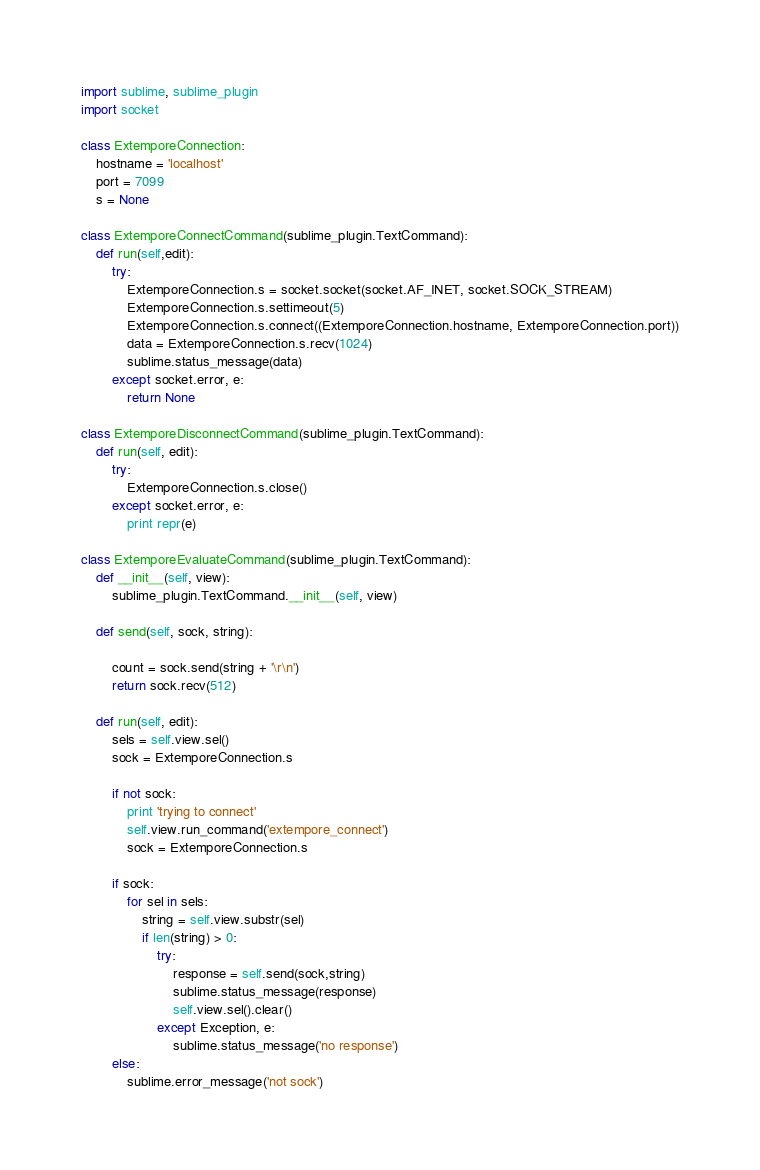<code> <loc_0><loc_0><loc_500><loc_500><_Python_>import sublime, sublime_plugin
import socket

class ExtemporeConnection:
	hostname = 'localhost'
	port = 7099
	s = None

class ExtemporeConnectCommand(sublime_plugin.TextCommand):
	def run(self,edit):
		try:
			ExtemporeConnection.s = socket.socket(socket.AF_INET, socket.SOCK_STREAM)
			ExtemporeConnection.s.settimeout(5)
			ExtemporeConnection.s.connect((ExtemporeConnection.hostname, ExtemporeConnection.port))
			data = ExtemporeConnection.s.recv(1024)
			sublime.status_message(data)
		except socket.error, e:
			return None

class ExtemporeDisconnectCommand(sublime_plugin.TextCommand):
	def run(self, edit):
		try:
			ExtemporeConnection.s.close()
		except socket.error, e:
			print repr(e)

class ExtemporeEvaluateCommand(sublime_plugin.TextCommand):
	def __init__(self, view):
		sublime_plugin.TextCommand.__init__(self, view)

	def send(self, sock, string):

		count = sock.send(string + '\r\n')
		return sock.recv(512)
		
	def run(self, edit):			
		sels = self.view.sel()
		sock = ExtemporeConnection.s

		if not sock:
			print 'trying to connect'
			self.view.run_command('extempore_connect')
			sock = ExtemporeConnection.s

		if sock:
			for sel in sels:
				string = self.view.substr(sel)
				if len(string) > 0:
					try:
						response = self.send(sock,string)
						sublime.status_message(response)
						self.view.sel().clear()
					except Exception, e:
						sublime.status_message('no response')
		else:
			sublime.error_message('not sock')

</code> 